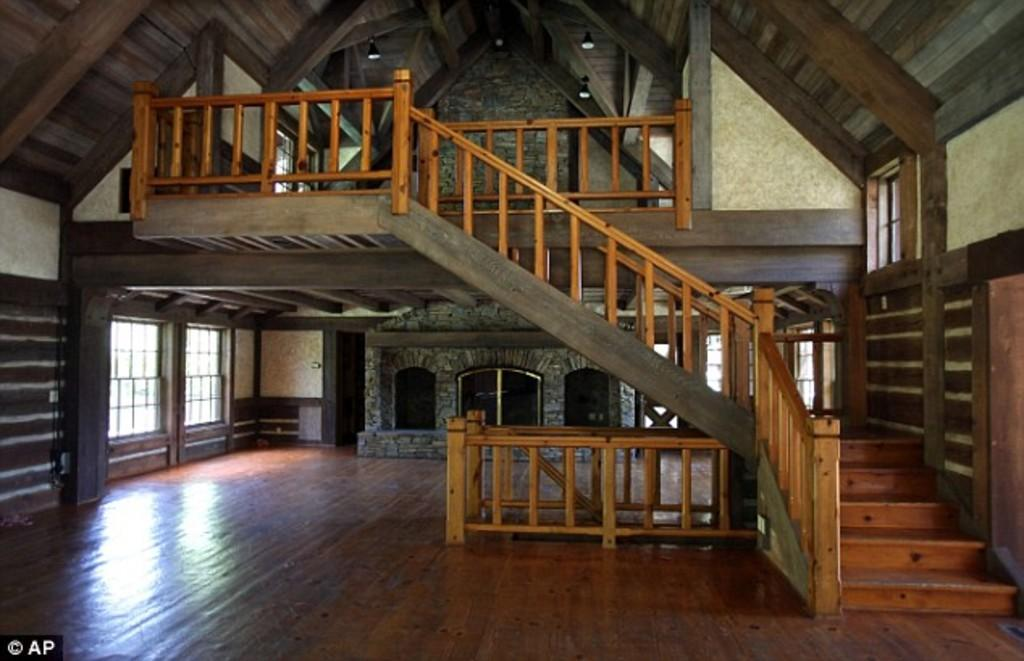What is the primary surface visible in the image? There is a floor in the image. What feature is present to provide support or guidance? There are railings in the image. What architectural element allows for changes in elevation? There are steps in the image. What structure separates the interior and exterior spaces? There is a wall in the image. What allows natural light to enter the space? There are glass windows in the image. What provides illumination in the image? There are lights in the image. Can you see the edge of the ocean in the image? There is no ocean present in the image; it features a floor, railings, steps, a wall, windows, and lights. 